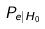<formula> <loc_0><loc_0><loc_500><loc_500>P _ { e | H _ { 0 } }</formula> 